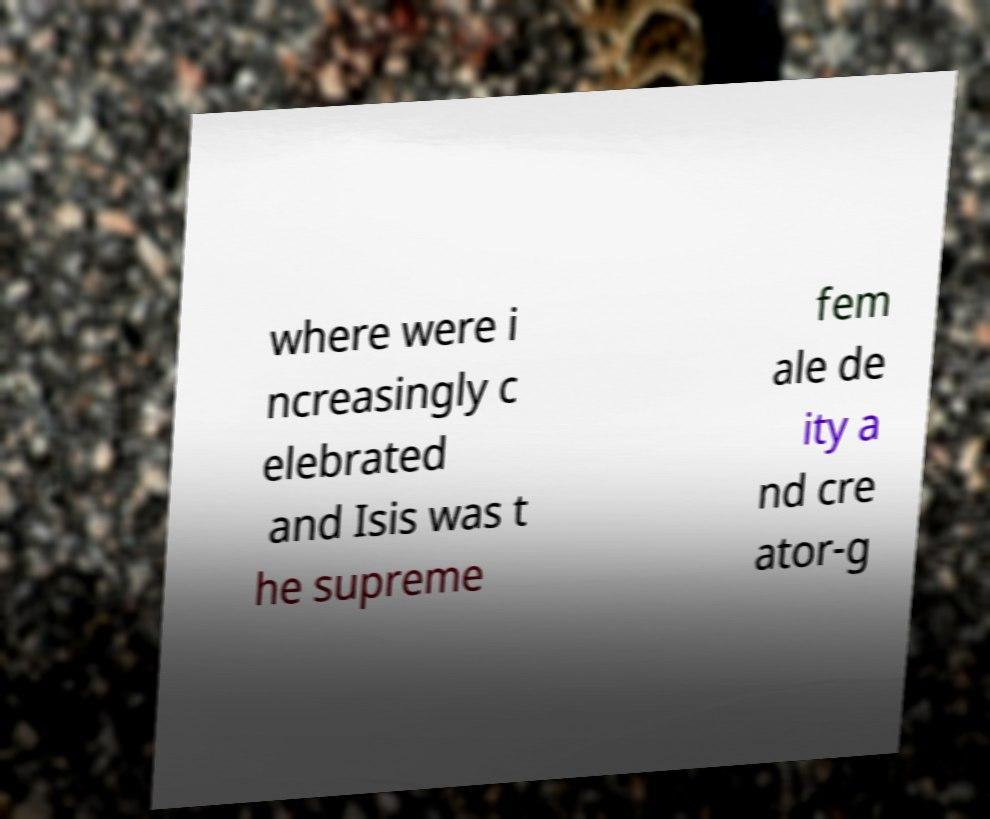There's text embedded in this image that I need extracted. Can you transcribe it verbatim? where were i ncreasingly c elebrated and Isis was t he supreme fem ale de ity a nd cre ator-g 